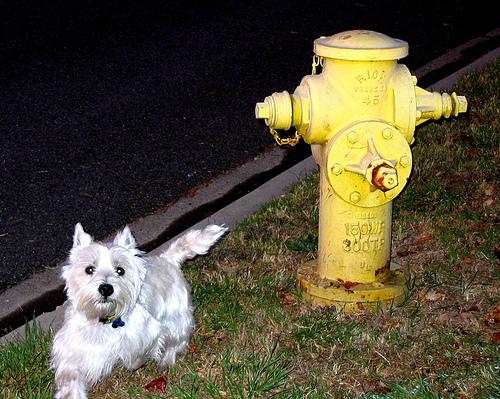How many dogs are there?
Write a very short answer. 1. Is there a kid here?
Give a very brief answer. No. Is the animal lying on a mowed lawn?
Quick response, please. Yes. What is next to the dog?
Concise answer only. Fire hydrant. What number of dogs are being walked?
Give a very brief answer. 1. Are there steps in the picture?
Short answer required. No. Where does it say "300"?
Keep it brief. Fire hydrant. Is the dog on the sidewalk?
Give a very brief answer. No. 